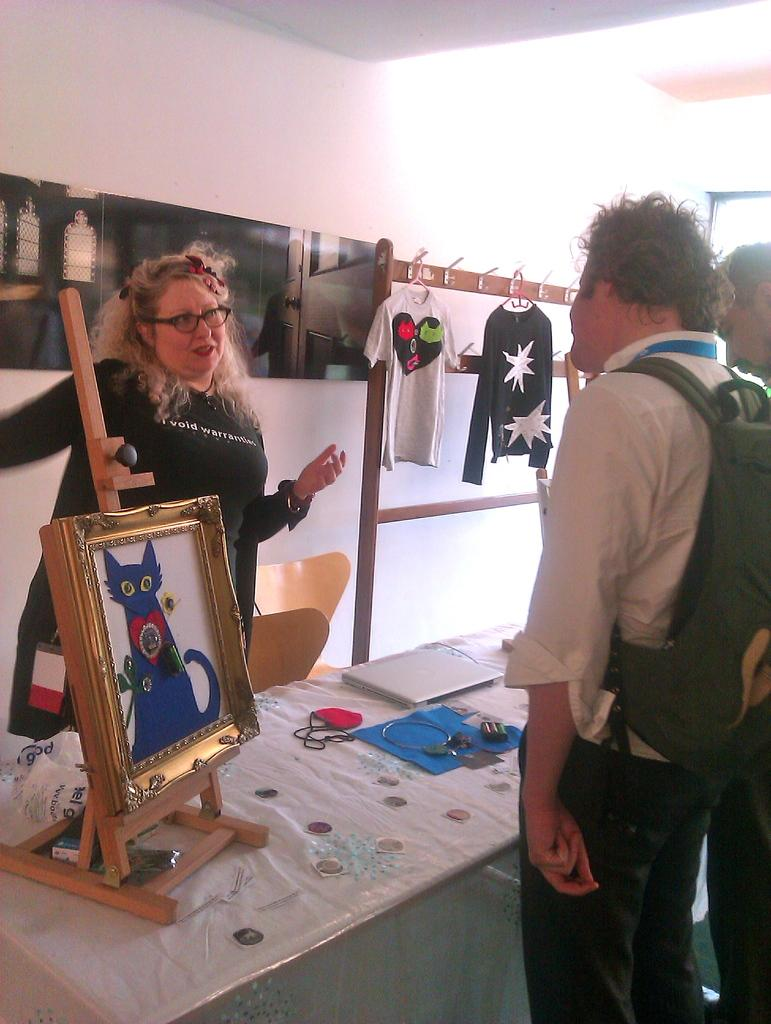How many people are in the image? There are two persons standing in the image. Where are the persons standing? The persons are standing on the floor. What can be seen on the table in the image? There is a frame on the table. What is visible in the background of the image? There is a wall in the background of the image. What type of clothing is visible in the image? There are t-shirts visible in the image. Are there any dinosaurs visible in the image? No, there are no dinosaurs present in the image. How deep is the quicksand in the image? There is no quicksand present in the image. 